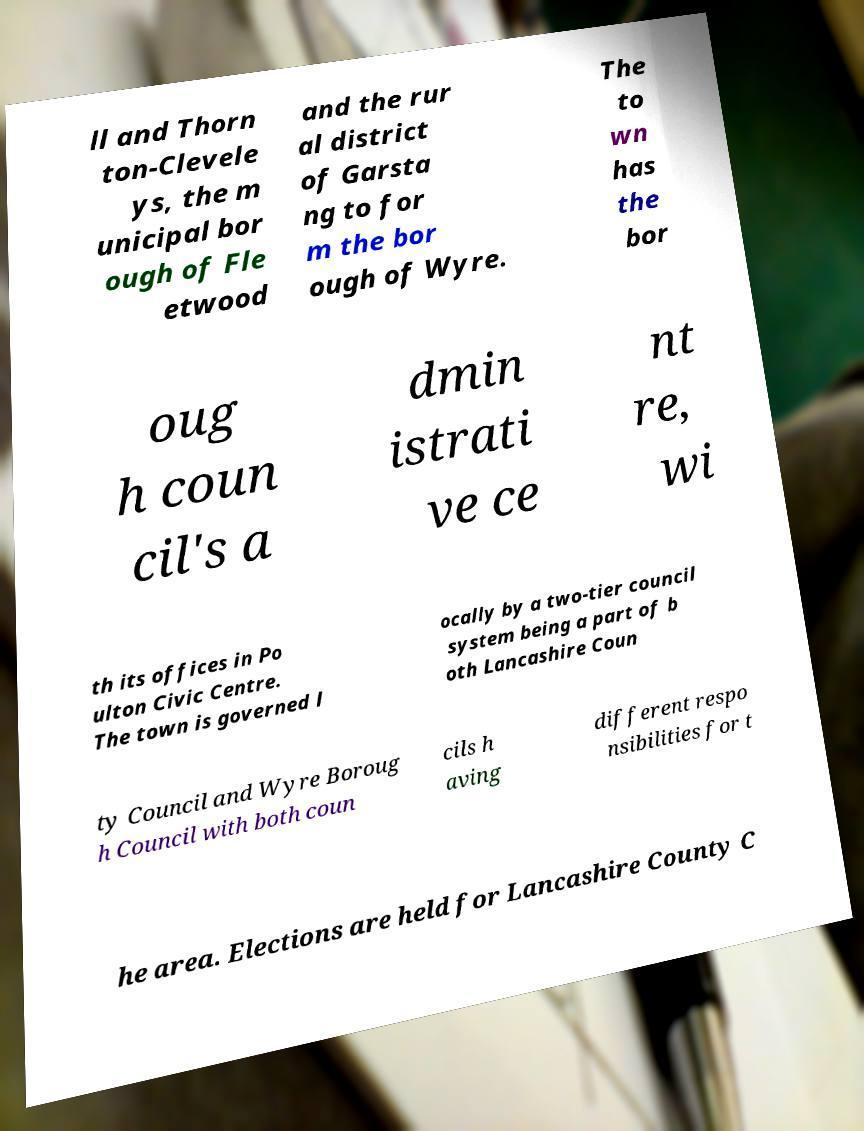Please identify and transcribe the text found in this image. ll and Thorn ton-Clevele ys, the m unicipal bor ough of Fle etwood and the rur al district of Garsta ng to for m the bor ough of Wyre. The to wn has the bor oug h coun cil's a dmin istrati ve ce nt re, wi th its offices in Po ulton Civic Centre. The town is governed l ocally by a two-tier council system being a part of b oth Lancashire Coun ty Council and Wyre Boroug h Council with both coun cils h aving different respo nsibilities for t he area. Elections are held for Lancashire County C 